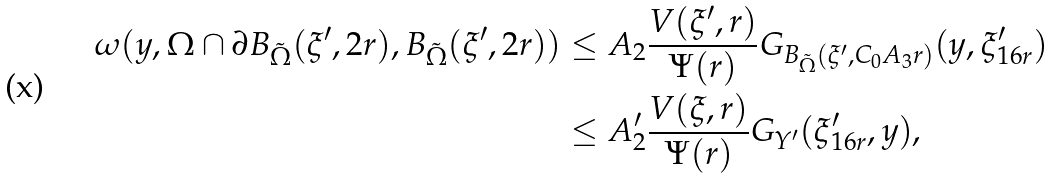Convert formula to latex. <formula><loc_0><loc_0><loc_500><loc_500>\omega ( y , \Omega \cap \partial B _ { \tilde { \Omega } } ( \xi ^ { \prime } , 2 r ) , B _ { \tilde { \Omega } } ( \xi ^ { \prime } , 2 r ) ) & \leq A _ { 2 } \frac { V ( \xi ^ { \prime } , r ) } { \Psi ( r ) } G _ { B _ { \tilde { \Omega } } ( \xi ^ { \prime } , C _ { 0 } A _ { 3 } r ) } ( y , \xi ^ { \prime } _ { 1 6 r } ) \\ & \leq A _ { 2 } ^ { \prime } \frac { V ( \xi , r ) } { \Psi ( r ) } G _ { Y ^ { \prime } } ( \xi ^ { \prime } _ { 1 6 r } , y ) ,</formula> 